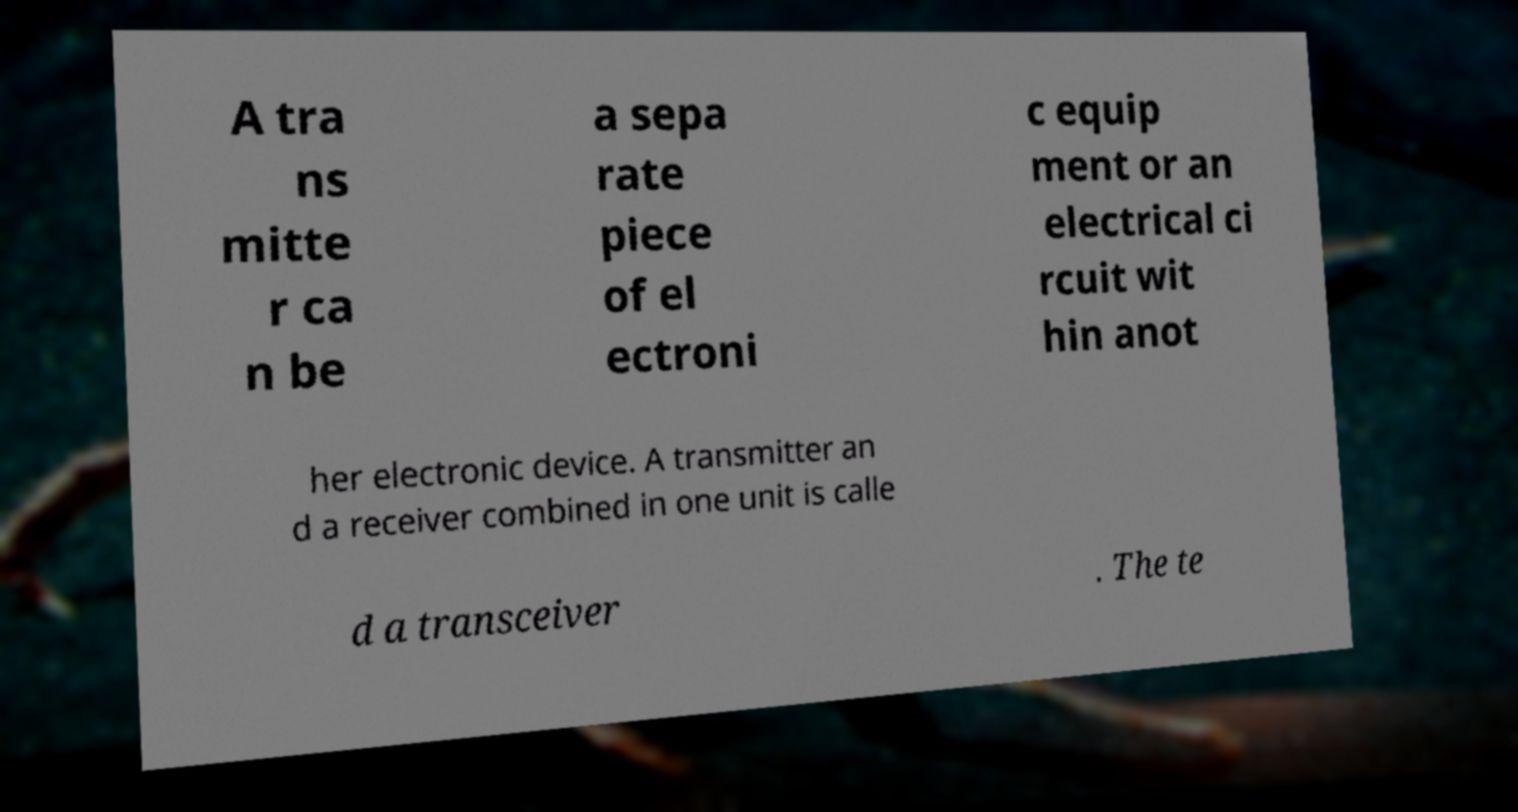Can you read and provide the text displayed in the image?This photo seems to have some interesting text. Can you extract and type it out for me? A tra ns mitte r ca n be a sepa rate piece of el ectroni c equip ment or an electrical ci rcuit wit hin anot her electronic device. A transmitter an d a receiver combined in one unit is calle d a transceiver . The te 